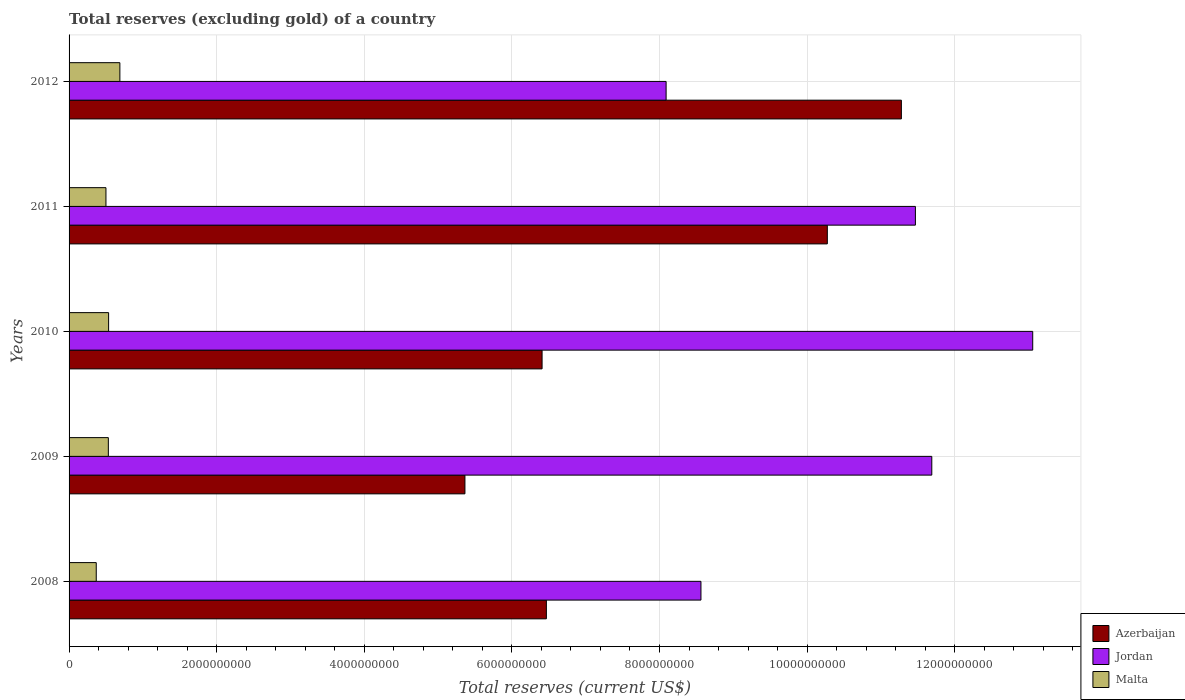How many groups of bars are there?
Your answer should be very brief. 5. Are the number of bars per tick equal to the number of legend labels?
Keep it short and to the point. Yes. Are the number of bars on each tick of the Y-axis equal?
Your answer should be very brief. Yes. In how many cases, is the number of bars for a given year not equal to the number of legend labels?
Offer a very short reply. 0. What is the total reserves (excluding gold) in Jordan in 2010?
Make the answer very short. 1.31e+1. Across all years, what is the maximum total reserves (excluding gold) in Malta?
Ensure brevity in your answer.  6.88e+08. Across all years, what is the minimum total reserves (excluding gold) in Azerbaijan?
Provide a short and direct response. 5.36e+09. In which year was the total reserves (excluding gold) in Malta maximum?
Your response must be concise. 2012. In which year was the total reserves (excluding gold) in Jordan minimum?
Provide a short and direct response. 2012. What is the total total reserves (excluding gold) in Malta in the graph?
Offer a very short reply. 2.62e+09. What is the difference between the total reserves (excluding gold) in Malta in 2010 and that in 2012?
Keep it short and to the point. -1.52e+08. What is the difference between the total reserves (excluding gold) in Azerbaijan in 2011 and the total reserves (excluding gold) in Malta in 2012?
Offer a terse response. 9.59e+09. What is the average total reserves (excluding gold) in Azerbaijan per year?
Your answer should be very brief. 7.96e+09. In the year 2010, what is the difference between the total reserves (excluding gold) in Azerbaijan and total reserves (excluding gold) in Malta?
Give a very brief answer. 5.87e+09. What is the ratio of the total reserves (excluding gold) in Azerbaijan in 2008 to that in 2009?
Provide a short and direct response. 1.21. What is the difference between the highest and the second highest total reserves (excluding gold) in Malta?
Offer a very short reply. 1.52e+08. What is the difference between the highest and the lowest total reserves (excluding gold) in Azerbaijan?
Offer a very short reply. 5.91e+09. Is the sum of the total reserves (excluding gold) in Malta in 2008 and 2010 greater than the maximum total reserves (excluding gold) in Azerbaijan across all years?
Your answer should be compact. No. What does the 2nd bar from the top in 2010 represents?
Your answer should be very brief. Jordan. What does the 3rd bar from the bottom in 2008 represents?
Your answer should be very brief. Malta. Are all the bars in the graph horizontal?
Make the answer very short. Yes. Are the values on the major ticks of X-axis written in scientific E-notation?
Provide a short and direct response. No. Does the graph contain any zero values?
Provide a short and direct response. No. Does the graph contain grids?
Offer a very short reply. Yes. Where does the legend appear in the graph?
Give a very brief answer. Bottom right. How many legend labels are there?
Your answer should be compact. 3. What is the title of the graph?
Provide a succinct answer. Total reserves (excluding gold) of a country. What is the label or title of the X-axis?
Provide a short and direct response. Total reserves (current US$). What is the label or title of the Y-axis?
Make the answer very short. Years. What is the Total reserves (current US$) in Azerbaijan in 2008?
Give a very brief answer. 6.47e+09. What is the Total reserves (current US$) of Jordan in 2008?
Ensure brevity in your answer.  8.56e+09. What is the Total reserves (current US$) of Malta in 2008?
Keep it short and to the point. 3.68e+08. What is the Total reserves (current US$) in Azerbaijan in 2009?
Your response must be concise. 5.36e+09. What is the Total reserves (current US$) in Jordan in 2009?
Provide a succinct answer. 1.17e+1. What is the Total reserves (current US$) of Malta in 2009?
Offer a terse response. 5.32e+08. What is the Total reserves (current US$) in Azerbaijan in 2010?
Provide a succinct answer. 6.41e+09. What is the Total reserves (current US$) of Jordan in 2010?
Your answer should be very brief. 1.31e+1. What is the Total reserves (current US$) in Malta in 2010?
Keep it short and to the point. 5.36e+08. What is the Total reserves (current US$) in Azerbaijan in 2011?
Ensure brevity in your answer.  1.03e+1. What is the Total reserves (current US$) in Jordan in 2011?
Offer a terse response. 1.15e+1. What is the Total reserves (current US$) in Malta in 2011?
Keep it short and to the point. 5.00e+08. What is the Total reserves (current US$) in Azerbaijan in 2012?
Ensure brevity in your answer.  1.13e+1. What is the Total reserves (current US$) in Jordan in 2012?
Your answer should be compact. 8.09e+09. What is the Total reserves (current US$) in Malta in 2012?
Keep it short and to the point. 6.88e+08. Across all years, what is the maximum Total reserves (current US$) in Azerbaijan?
Provide a short and direct response. 1.13e+1. Across all years, what is the maximum Total reserves (current US$) of Jordan?
Provide a short and direct response. 1.31e+1. Across all years, what is the maximum Total reserves (current US$) in Malta?
Your answer should be very brief. 6.88e+08. Across all years, what is the minimum Total reserves (current US$) of Azerbaijan?
Ensure brevity in your answer.  5.36e+09. Across all years, what is the minimum Total reserves (current US$) in Jordan?
Your response must be concise. 8.09e+09. Across all years, what is the minimum Total reserves (current US$) in Malta?
Ensure brevity in your answer.  3.68e+08. What is the total Total reserves (current US$) in Azerbaijan in the graph?
Your answer should be compact. 3.98e+1. What is the total Total reserves (current US$) in Jordan in the graph?
Your answer should be compact. 5.29e+1. What is the total Total reserves (current US$) in Malta in the graph?
Offer a very short reply. 2.62e+09. What is the difference between the Total reserves (current US$) in Azerbaijan in 2008 and that in 2009?
Offer a terse response. 1.10e+09. What is the difference between the Total reserves (current US$) in Jordan in 2008 and that in 2009?
Ensure brevity in your answer.  -3.13e+09. What is the difference between the Total reserves (current US$) in Malta in 2008 and that in 2009?
Your response must be concise. -1.64e+08. What is the difference between the Total reserves (current US$) of Azerbaijan in 2008 and that in 2010?
Ensure brevity in your answer.  5.83e+07. What is the difference between the Total reserves (current US$) in Jordan in 2008 and that in 2010?
Offer a very short reply. -4.50e+09. What is the difference between the Total reserves (current US$) of Malta in 2008 and that in 2010?
Your answer should be very brief. -1.68e+08. What is the difference between the Total reserves (current US$) in Azerbaijan in 2008 and that in 2011?
Your answer should be very brief. -3.81e+09. What is the difference between the Total reserves (current US$) in Jordan in 2008 and that in 2011?
Give a very brief answer. -2.91e+09. What is the difference between the Total reserves (current US$) of Malta in 2008 and that in 2011?
Your response must be concise. -1.31e+08. What is the difference between the Total reserves (current US$) in Azerbaijan in 2008 and that in 2012?
Keep it short and to the point. -4.81e+09. What is the difference between the Total reserves (current US$) of Jordan in 2008 and that in 2012?
Provide a succinct answer. 4.72e+08. What is the difference between the Total reserves (current US$) in Malta in 2008 and that in 2012?
Offer a very short reply. -3.20e+08. What is the difference between the Total reserves (current US$) in Azerbaijan in 2009 and that in 2010?
Your answer should be very brief. -1.05e+09. What is the difference between the Total reserves (current US$) in Jordan in 2009 and that in 2010?
Make the answer very short. -1.37e+09. What is the difference between the Total reserves (current US$) of Malta in 2009 and that in 2010?
Your answer should be compact. -3.70e+06. What is the difference between the Total reserves (current US$) in Azerbaijan in 2009 and that in 2011?
Offer a very short reply. -4.91e+09. What is the difference between the Total reserves (current US$) in Jordan in 2009 and that in 2011?
Ensure brevity in your answer.  2.22e+08. What is the difference between the Total reserves (current US$) in Malta in 2009 and that in 2011?
Offer a very short reply. 3.23e+07. What is the difference between the Total reserves (current US$) in Azerbaijan in 2009 and that in 2012?
Your response must be concise. -5.91e+09. What is the difference between the Total reserves (current US$) of Jordan in 2009 and that in 2012?
Provide a succinct answer. 3.60e+09. What is the difference between the Total reserves (current US$) of Malta in 2009 and that in 2012?
Your answer should be very brief. -1.56e+08. What is the difference between the Total reserves (current US$) in Azerbaijan in 2010 and that in 2011?
Provide a short and direct response. -3.86e+09. What is the difference between the Total reserves (current US$) of Jordan in 2010 and that in 2011?
Provide a short and direct response. 1.59e+09. What is the difference between the Total reserves (current US$) in Malta in 2010 and that in 2011?
Make the answer very short. 3.60e+07. What is the difference between the Total reserves (current US$) in Azerbaijan in 2010 and that in 2012?
Offer a terse response. -4.87e+09. What is the difference between the Total reserves (current US$) of Jordan in 2010 and that in 2012?
Provide a short and direct response. 4.97e+09. What is the difference between the Total reserves (current US$) in Malta in 2010 and that in 2012?
Ensure brevity in your answer.  -1.52e+08. What is the difference between the Total reserves (current US$) of Azerbaijan in 2011 and that in 2012?
Your answer should be very brief. -1.00e+09. What is the difference between the Total reserves (current US$) of Jordan in 2011 and that in 2012?
Offer a terse response. 3.38e+09. What is the difference between the Total reserves (current US$) in Malta in 2011 and that in 2012?
Give a very brief answer. -1.88e+08. What is the difference between the Total reserves (current US$) in Azerbaijan in 2008 and the Total reserves (current US$) in Jordan in 2009?
Your answer should be very brief. -5.22e+09. What is the difference between the Total reserves (current US$) in Azerbaijan in 2008 and the Total reserves (current US$) in Malta in 2009?
Keep it short and to the point. 5.94e+09. What is the difference between the Total reserves (current US$) of Jordan in 2008 and the Total reserves (current US$) of Malta in 2009?
Give a very brief answer. 8.03e+09. What is the difference between the Total reserves (current US$) in Azerbaijan in 2008 and the Total reserves (current US$) in Jordan in 2010?
Your answer should be compact. -6.59e+09. What is the difference between the Total reserves (current US$) in Azerbaijan in 2008 and the Total reserves (current US$) in Malta in 2010?
Give a very brief answer. 5.93e+09. What is the difference between the Total reserves (current US$) in Jordan in 2008 and the Total reserves (current US$) in Malta in 2010?
Offer a terse response. 8.03e+09. What is the difference between the Total reserves (current US$) of Azerbaijan in 2008 and the Total reserves (current US$) of Jordan in 2011?
Make the answer very short. -5.00e+09. What is the difference between the Total reserves (current US$) of Azerbaijan in 2008 and the Total reserves (current US$) of Malta in 2011?
Ensure brevity in your answer.  5.97e+09. What is the difference between the Total reserves (current US$) of Jordan in 2008 and the Total reserves (current US$) of Malta in 2011?
Your answer should be very brief. 8.06e+09. What is the difference between the Total reserves (current US$) in Azerbaijan in 2008 and the Total reserves (current US$) in Jordan in 2012?
Keep it short and to the point. -1.62e+09. What is the difference between the Total reserves (current US$) in Azerbaijan in 2008 and the Total reserves (current US$) in Malta in 2012?
Give a very brief answer. 5.78e+09. What is the difference between the Total reserves (current US$) in Jordan in 2008 and the Total reserves (current US$) in Malta in 2012?
Your response must be concise. 7.87e+09. What is the difference between the Total reserves (current US$) of Azerbaijan in 2009 and the Total reserves (current US$) of Jordan in 2010?
Give a very brief answer. -7.69e+09. What is the difference between the Total reserves (current US$) in Azerbaijan in 2009 and the Total reserves (current US$) in Malta in 2010?
Offer a very short reply. 4.83e+09. What is the difference between the Total reserves (current US$) in Jordan in 2009 and the Total reserves (current US$) in Malta in 2010?
Provide a succinct answer. 1.12e+1. What is the difference between the Total reserves (current US$) of Azerbaijan in 2009 and the Total reserves (current US$) of Jordan in 2011?
Make the answer very short. -6.10e+09. What is the difference between the Total reserves (current US$) of Azerbaijan in 2009 and the Total reserves (current US$) of Malta in 2011?
Offer a terse response. 4.86e+09. What is the difference between the Total reserves (current US$) of Jordan in 2009 and the Total reserves (current US$) of Malta in 2011?
Give a very brief answer. 1.12e+1. What is the difference between the Total reserves (current US$) in Azerbaijan in 2009 and the Total reserves (current US$) in Jordan in 2012?
Offer a very short reply. -2.73e+09. What is the difference between the Total reserves (current US$) of Azerbaijan in 2009 and the Total reserves (current US$) of Malta in 2012?
Offer a terse response. 4.68e+09. What is the difference between the Total reserves (current US$) in Jordan in 2009 and the Total reserves (current US$) in Malta in 2012?
Ensure brevity in your answer.  1.10e+1. What is the difference between the Total reserves (current US$) in Azerbaijan in 2010 and the Total reserves (current US$) in Jordan in 2011?
Keep it short and to the point. -5.06e+09. What is the difference between the Total reserves (current US$) in Azerbaijan in 2010 and the Total reserves (current US$) in Malta in 2011?
Keep it short and to the point. 5.91e+09. What is the difference between the Total reserves (current US$) of Jordan in 2010 and the Total reserves (current US$) of Malta in 2011?
Provide a succinct answer. 1.26e+1. What is the difference between the Total reserves (current US$) in Azerbaijan in 2010 and the Total reserves (current US$) in Jordan in 2012?
Your answer should be compact. -1.68e+09. What is the difference between the Total reserves (current US$) in Azerbaijan in 2010 and the Total reserves (current US$) in Malta in 2012?
Provide a short and direct response. 5.72e+09. What is the difference between the Total reserves (current US$) in Jordan in 2010 and the Total reserves (current US$) in Malta in 2012?
Your response must be concise. 1.24e+1. What is the difference between the Total reserves (current US$) of Azerbaijan in 2011 and the Total reserves (current US$) of Jordan in 2012?
Keep it short and to the point. 2.18e+09. What is the difference between the Total reserves (current US$) in Azerbaijan in 2011 and the Total reserves (current US$) in Malta in 2012?
Your answer should be very brief. 9.59e+09. What is the difference between the Total reserves (current US$) in Jordan in 2011 and the Total reserves (current US$) in Malta in 2012?
Ensure brevity in your answer.  1.08e+1. What is the average Total reserves (current US$) in Azerbaijan per year?
Keep it short and to the point. 7.96e+09. What is the average Total reserves (current US$) in Jordan per year?
Give a very brief answer. 1.06e+1. What is the average Total reserves (current US$) in Malta per year?
Keep it short and to the point. 5.25e+08. In the year 2008, what is the difference between the Total reserves (current US$) in Azerbaijan and Total reserves (current US$) in Jordan?
Provide a short and direct response. -2.09e+09. In the year 2008, what is the difference between the Total reserves (current US$) in Azerbaijan and Total reserves (current US$) in Malta?
Your response must be concise. 6.10e+09. In the year 2008, what is the difference between the Total reserves (current US$) of Jordan and Total reserves (current US$) of Malta?
Keep it short and to the point. 8.19e+09. In the year 2009, what is the difference between the Total reserves (current US$) in Azerbaijan and Total reserves (current US$) in Jordan?
Ensure brevity in your answer.  -6.33e+09. In the year 2009, what is the difference between the Total reserves (current US$) of Azerbaijan and Total reserves (current US$) of Malta?
Give a very brief answer. 4.83e+09. In the year 2009, what is the difference between the Total reserves (current US$) in Jordan and Total reserves (current US$) in Malta?
Your response must be concise. 1.12e+1. In the year 2010, what is the difference between the Total reserves (current US$) of Azerbaijan and Total reserves (current US$) of Jordan?
Your answer should be very brief. -6.65e+09. In the year 2010, what is the difference between the Total reserves (current US$) in Azerbaijan and Total reserves (current US$) in Malta?
Ensure brevity in your answer.  5.87e+09. In the year 2010, what is the difference between the Total reserves (current US$) of Jordan and Total reserves (current US$) of Malta?
Offer a terse response. 1.25e+1. In the year 2011, what is the difference between the Total reserves (current US$) of Azerbaijan and Total reserves (current US$) of Jordan?
Your answer should be very brief. -1.19e+09. In the year 2011, what is the difference between the Total reserves (current US$) in Azerbaijan and Total reserves (current US$) in Malta?
Offer a very short reply. 9.77e+09. In the year 2011, what is the difference between the Total reserves (current US$) of Jordan and Total reserves (current US$) of Malta?
Offer a terse response. 1.10e+1. In the year 2012, what is the difference between the Total reserves (current US$) in Azerbaijan and Total reserves (current US$) in Jordan?
Provide a succinct answer. 3.19e+09. In the year 2012, what is the difference between the Total reserves (current US$) in Azerbaijan and Total reserves (current US$) in Malta?
Keep it short and to the point. 1.06e+1. In the year 2012, what is the difference between the Total reserves (current US$) in Jordan and Total reserves (current US$) in Malta?
Make the answer very short. 7.40e+09. What is the ratio of the Total reserves (current US$) in Azerbaijan in 2008 to that in 2009?
Give a very brief answer. 1.21. What is the ratio of the Total reserves (current US$) of Jordan in 2008 to that in 2009?
Your answer should be compact. 0.73. What is the ratio of the Total reserves (current US$) in Malta in 2008 to that in 2009?
Give a very brief answer. 0.69. What is the ratio of the Total reserves (current US$) in Azerbaijan in 2008 to that in 2010?
Your response must be concise. 1.01. What is the ratio of the Total reserves (current US$) of Jordan in 2008 to that in 2010?
Ensure brevity in your answer.  0.66. What is the ratio of the Total reserves (current US$) of Malta in 2008 to that in 2010?
Your answer should be very brief. 0.69. What is the ratio of the Total reserves (current US$) of Azerbaijan in 2008 to that in 2011?
Make the answer very short. 0.63. What is the ratio of the Total reserves (current US$) in Jordan in 2008 to that in 2011?
Provide a succinct answer. 0.75. What is the ratio of the Total reserves (current US$) in Malta in 2008 to that in 2011?
Keep it short and to the point. 0.74. What is the ratio of the Total reserves (current US$) of Azerbaijan in 2008 to that in 2012?
Provide a succinct answer. 0.57. What is the ratio of the Total reserves (current US$) in Jordan in 2008 to that in 2012?
Ensure brevity in your answer.  1.06. What is the ratio of the Total reserves (current US$) in Malta in 2008 to that in 2012?
Provide a short and direct response. 0.54. What is the ratio of the Total reserves (current US$) in Azerbaijan in 2009 to that in 2010?
Your answer should be compact. 0.84. What is the ratio of the Total reserves (current US$) in Jordan in 2009 to that in 2010?
Keep it short and to the point. 0.9. What is the ratio of the Total reserves (current US$) of Malta in 2009 to that in 2010?
Provide a succinct answer. 0.99. What is the ratio of the Total reserves (current US$) of Azerbaijan in 2009 to that in 2011?
Your response must be concise. 0.52. What is the ratio of the Total reserves (current US$) of Jordan in 2009 to that in 2011?
Make the answer very short. 1.02. What is the ratio of the Total reserves (current US$) in Malta in 2009 to that in 2011?
Keep it short and to the point. 1.06. What is the ratio of the Total reserves (current US$) of Azerbaijan in 2009 to that in 2012?
Ensure brevity in your answer.  0.48. What is the ratio of the Total reserves (current US$) of Jordan in 2009 to that in 2012?
Ensure brevity in your answer.  1.45. What is the ratio of the Total reserves (current US$) of Malta in 2009 to that in 2012?
Offer a very short reply. 0.77. What is the ratio of the Total reserves (current US$) of Azerbaijan in 2010 to that in 2011?
Keep it short and to the point. 0.62. What is the ratio of the Total reserves (current US$) in Jordan in 2010 to that in 2011?
Give a very brief answer. 1.14. What is the ratio of the Total reserves (current US$) in Malta in 2010 to that in 2011?
Give a very brief answer. 1.07. What is the ratio of the Total reserves (current US$) in Azerbaijan in 2010 to that in 2012?
Keep it short and to the point. 0.57. What is the ratio of the Total reserves (current US$) in Jordan in 2010 to that in 2012?
Offer a terse response. 1.61. What is the ratio of the Total reserves (current US$) of Malta in 2010 to that in 2012?
Provide a short and direct response. 0.78. What is the ratio of the Total reserves (current US$) in Azerbaijan in 2011 to that in 2012?
Your answer should be very brief. 0.91. What is the ratio of the Total reserves (current US$) of Jordan in 2011 to that in 2012?
Offer a terse response. 1.42. What is the ratio of the Total reserves (current US$) of Malta in 2011 to that in 2012?
Make the answer very short. 0.73. What is the difference between the highest and the second highest Total reserves (current US$) of Azerbaijan?
Your answer should be compact. 1.00e+09. What is the difference between the highest and the second highest Total reserves (current US$) in Jordan?
Make the answer very short. 1.37e+09. What is the difference between the highest and the second highest Total reserves (current US$) of Malta?
Ensure brevity in your answer.  1.52e+08. What is the difference between the highest and the lowest Total reserves (current US$) of Azerbaijan?
Keep it short and to the point. 5.91e+09. What is the difference between the highest and the lowest Total reserves (current US$) of Jordan?
Make the answer very short. 4.97e+09. What is the difference between the highest and the lowest Total reserves (current US$) of Malta?
Your response must be concise. 3.20e+08. 